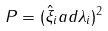<formula> <loc_0><loc_0><loc_500><loc_500>P = ( \hat { \xi } _ { i } a d \lambda _ { i } ) ^ { 2 }</formula> 